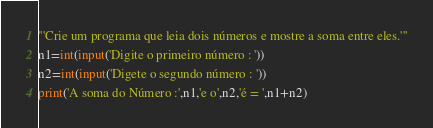<code> <loc_0><loc_0><loc_500><loc_500><_Python_>'''Crie um programa que leia dois números e mostre a soma entre eles.'''
n1=int(input('Digite o primeiro número : '))
n2=int(input('Digete o segundo número : '))
print('A soma do Número :',n1,'e o',n2,'é = ',n1+n2)</code> 